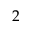<formula> <loc_0><loc_0><loc_500><loc_500>2</formula> 